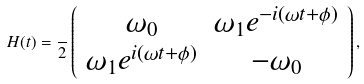<formula> <loc_0><loc_0><loc_500><loc_500>H ( t ) = \frac { } { 2 } \left ( \begin{array} { c c } \omega _ { 0 } & \omega _ { 1 } e ^ { - i ( \omega t + \phi ) } \\ \omega _ { 1 } e ^ { i ( \omega t + \phi ) } & - \omega _ { 0 } \end{array} \right ) ,</formula> 